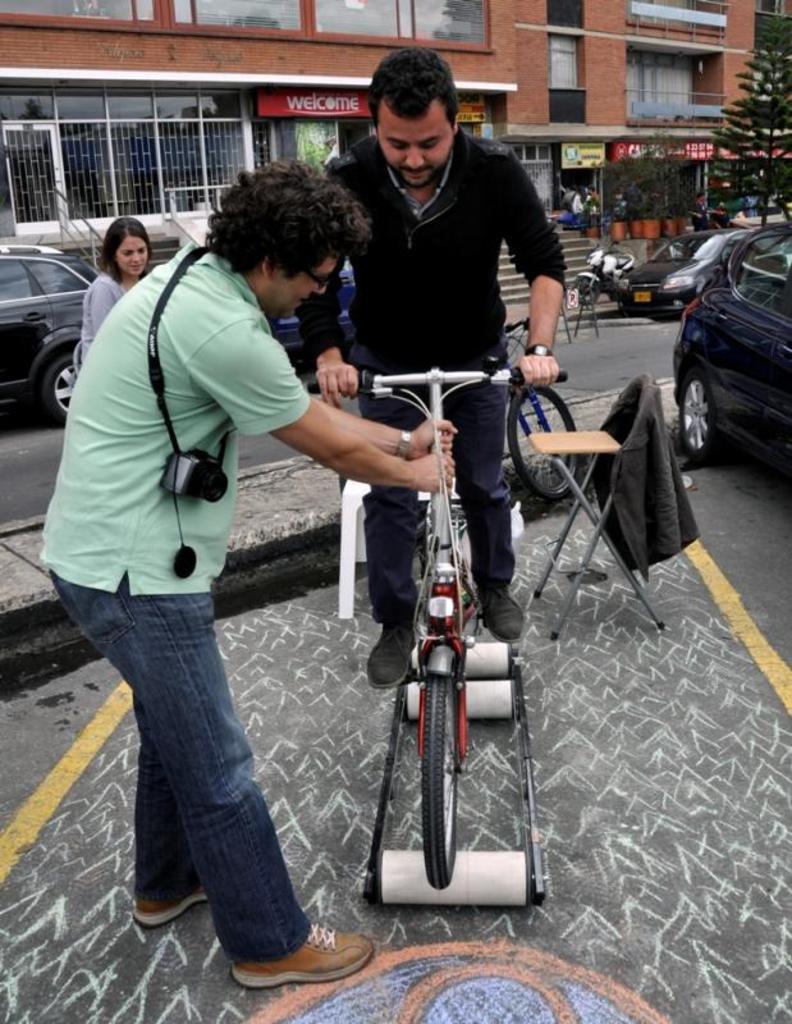Please provide a concise description of this image. In the given image we can see two boys and a girl. The boy sitting on a bicycle, there are many vehicle around and a building. 